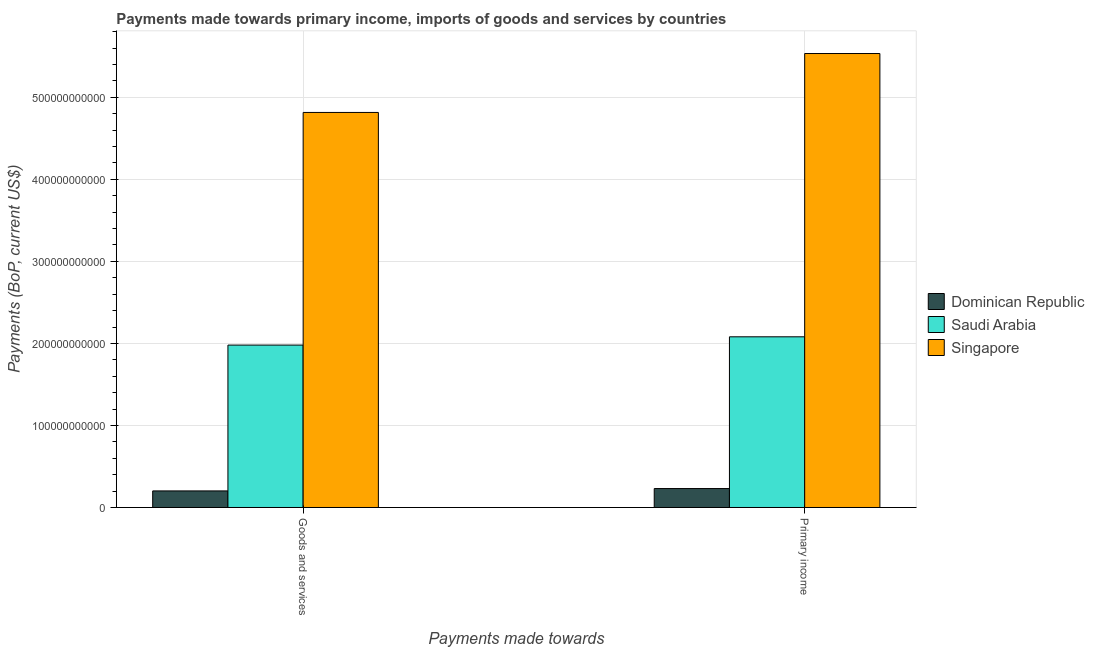How many groups of bars are there?
Your response must be concise. 2. How many bars are there on the 2nd tick from the left?
Your response must be concise. 3. What is the label of the 1st group of bars from the left?
Ensure brevity in your answer.  Goods and services. What is the payments made towards goods and services in Dominican Republic?
Provide a short and direct response. 2.02e+1. Across all countries, what is the maximum payments made towards primary income?
Ensure brevity in your answer.  5.53e+11. Across all countries, what is the minimum payments made towards primary income?
Provide a short and direct response. 2.31e+1. In which country was the payments made towards primary income maximum?
Provide a short and direct response. Singapore. In which country was the payments made towards primary income minimum?
Provide a succinct answer. Dominican Republic. What is the total payments made towards goods and services in the graph?
Ensure brevity in your answer.  7.00e+11. What is the difference between the payments made towards primary income in Singapore and that in Dominican Republic?
Give a very brief answer. 5.30e+11. What is the difference between the payments made towards goods and services in Dominican Republic and the payments made towards primary income in Saudi Arabia?
Make the answer very short. -1.88e+11. What is the average payments made towards goods and services per country?
Provide a short and direct response. 2.33e+11. What is the difference between the payments made towards primary income and payments made towards goods and services in Saudi Arabia?
Offer a terse response. 1.01e+1. What is the ratio of the payments made towards goods and services in Singapore to that in Saudi Arabia?
Provide a short and direct response. 2.43. Is the payments made towards primary income in Singapore less than that in Dominican Republic?
Your response must be concise. No. In how many countries, is the payments made towards goods and services greater than the average payments made towards goods and services taken over all countries?
Your answer should be compact. 1. What does the 2nd bar from the left in Primary income represents?
Give a very brief answer. Saudi Arabia. What does the 2nd bar from the right in Goods and services represents?
Ensure brevity in your answer.  Saudi Arabia. Are all the bars in the graph horizontal?
Your answer should be compact. No. What is the difference between two consecutive major ticks on the Y-axis?
Your answer should be very brief. 1.00e+11. Does the graph contain any zero values?
Your answer should be very brief. No. Does the graph contain grids?
Give a very brief answer. Yes. Where does the legend appear in the graph?
Make the answer very short. Center right. How many legend labels are there?
Your answer should be compact. 3. How are the legend labels stacked?
Offer a very short reply. Vertical. What is the title of the graph?
Offer a very short reply. Payments made towards primary income, imports of goods and services by countries. Does "Bermuda" appear as one of the legend labels in the graph?
Provide a succinct answer. No. What is the label or title of the X-axis?
Your response must be concise. Payments made towards. What is the label or title of the Y-axis?
Provide a succinct answer. Payments (BoP, current US$). What is the Payments (BoP, current US$) of Dominican Republic in Goods and services?
Make the answer very short. 2.02e+1. What is the Payments (BoP, current US$) in Saudi Arabia in Goods and services?
Provide a short and direct response. 1.98e+11. What is the Payments (BoP, current US$) in Singapore in Goods and services?
Keep it short and to the point. 4.82e+11. What is the Payments (BoP, current US$) of Dominican Republic in Primary income?
Your response must be concise. 2.31e+1. What is the Payments (BoP, current US$) in Saudi Arabia in Primary income?
Your answer should be very brief. 2.08e+11. What is the Payments (BoP, current US$) in Singapore in Primary income?
Offer a terse response. 5.53e+11. Across all Payments made towards, what is the maximum Payments (BoP, current US$) in Dominican Republic?
Keep it short and to the point. 2.31e+1. Across all Payments made towards, what is the maximum Payments (BoP, current US$) in Saudi Arabia?
Your response must be concise. 2.08e+11. Across all Payments made towards, what is the maximum Payments (BoP, current US$) in Singapore?
Ensure brevity in your answer.  5.53e+11. Across all Payments made towards, what is the minimum Payments (BoP, current US$) of Dominican Republic?
Offer a terse response. 2.02e+1. Across all Payments made towards, what is the minimum Payments (BoP, current US$) of Saudi Arabia?
Offer a very short reply. 1.98e+11. Across all Payments made towards, what is the minimum Payments (BoP, current US$) of Singapore?
Provide a succinct answer. 4.82e+11. What is the total Payments (BoP, current US$) in Dominican Republic in the graph?
Keep it short and to the point. 4.33e+1. What is the total Payments (BoP, current US$) in Saudi Arabia in the graph?
Your answer should be compact. 4.06e+11. What is the total Payments (BoP, current US$) in Singapore in the graph?
Offer a terse response. 1.03e+12. What is the difference between the Payments (BoP, current US$) of Dominican Republic in Goods and services and that in Primary income?
Your response must be concise. -2.88e+09. What is the difference between the Payments (BoP, current US$) in Saudi Arabia in Goods and services and that in Primary income?
Make the answer very short. -1.01e+1. What is the difference between the Payments (BoP, current US$) of Singapore in Goods and services and that in Primary income?
Provide a succinct answer. -7.18e+1. What is the difference between the Payments (BoP, current US$) of Dominican Republic in Goods and services and the Payments (BoP, current US$) of Saudi Arabia in Primary income?
Your response must be concise. -1.88e+11. What is the difference between the Payments (BoP, current US$) of Dominican Republic in Goods and services and the Payments (BoP, current US$) of Singapore in Primary income?
Provide a short and direct response. -5.33e+11. What is the difference between the Payments (BoP, current US$) of Saudi Arabia in Goods and services and the Payments (BoP, current US$) of Singapore in Primary income?
Give a very brief answer. -3.55e+11. What is the average Payments (BoP, current US$) of Dominican Republic per Payments made towards?
Your response must be concise. 2.16e+1. What is the average Payments (BoP, current US$) in Saudi Arabia per Payments made towards?
Offer a very short reply. 2.03e+11. What is the average Payments (BoP, current US$) in Singapore per Payments made towards?
Keep it short and to the point. 5.17e+11. What is the difference between the Payments (BoP, current US$) of Dominican Republic and Payments (BoP, current US$) of Saudi Arabia in Goods and services?
Provide a succinct answer. -1.78e+11. What is the difference between the Payments (BoP, current US$) of Dominican Republic and Payments (BoP, current US$) of Singapore in Goods and services?
Offer a terse response. -4.61e+11. What is the difference between the Payments (BoP, current US$) of Saudi Arabia and Payments (BoP, current US$) of Singapore in Goods and services?
Ensure brevity in your answer.  -2.84e+11. What is the difference between the Payments (BoP, current US$) in Dominican Republic and Payments (BoP, current US$) in Saudi Arabia in Primary income?
Offer a very short reply. -1.85e+11. What is the difference between the Payments (BoP, current US$) in Dominican Republic and Payments (BoP, current US$) in Singapore in Primary income?
Your answer should be very brief. -5.30e+11. What is the difference between the Payments (BoP, current US$) of Saudi Arabia and Payments (BoP, current US$) of Singapore in Primary income?
Ensure brevity in your answer.  -3.45e+11. What is the ratio of the Payments (BoP, current US$) in Dominican Republic in Goods and services to that in Primary income?
Your response must be concise. 0.88. What is the ratio of the Payments (BoP, current US$) of Saudi Arabia in Goods and services to that in Primary income?
Make the answer very short. 0.95. What is the ratio of the Payments (BoP, current US$) of Singapore in Goods and services to that in Primary income?
Make the answer very short. 0.87. What is the difference between the highest and the second highest Payments (BoP, current US$) in Dominican Republic?
Make the answer very short. 2.88e+09. What is the difference between the highest and the second highest Payments (BoP, current US$) in Saudi Arabia?
Give a very brief answer. 1.01e+1. What is the difference between the highest and the second highest Payments (BoP, current US$) in Singapore?
Keep it short and to the point. 7.18e+1. What is the difference between the highest and the lowest Payments (BoP, current US$) in Dominican Republic?
Your answer should be compact. 2.88e+09. What is the difference between the highest and the lowest Payments (BoP, current US$) of Saudi Arabia?
Your response must be concise. 1.01e+1. What is the difference between the highest and the lowest Payments (BoP, current US$) of Singapore?
Your answer should be compact. 7.18e+1. 